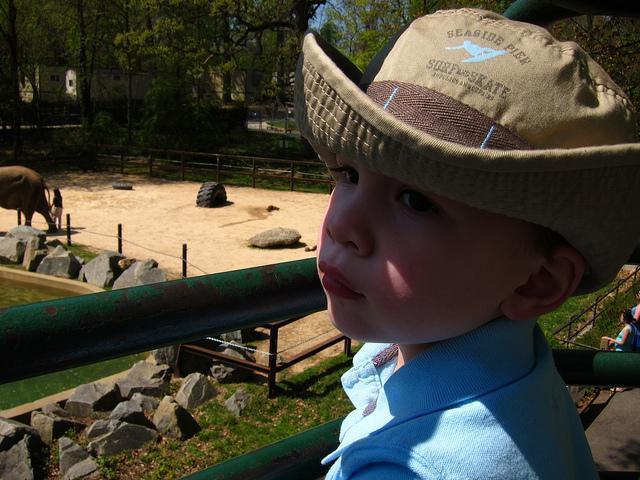How many elephants are there?
Give a very brief answer. 1. How many pieces is the sandwich cut in to?
Give a very brief answer. 0. 